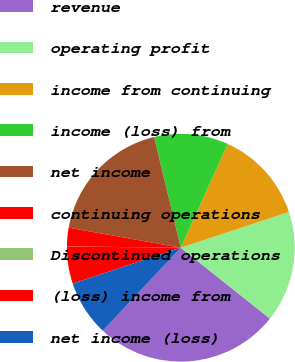<chart> <loc_0><loc_0><loc_500><loc_500><pie_chart><fcel>revenue<fcel>operating profit<fcel>income from continuing<fcel>income (loss) from<fcel>net income<fcel>continuing operations<fcel>Discontinued operations<fcel>(loss) income from<fcel>net income (loss)<nl><fcel>26.3%<fcel>15.78%<fcel>13.16%<fcel>10.53%<fcel>18.41%<fcel>2.64%<fcel>0.01%<fcel>5.27%<fcel>7.9%<nl></chart> 